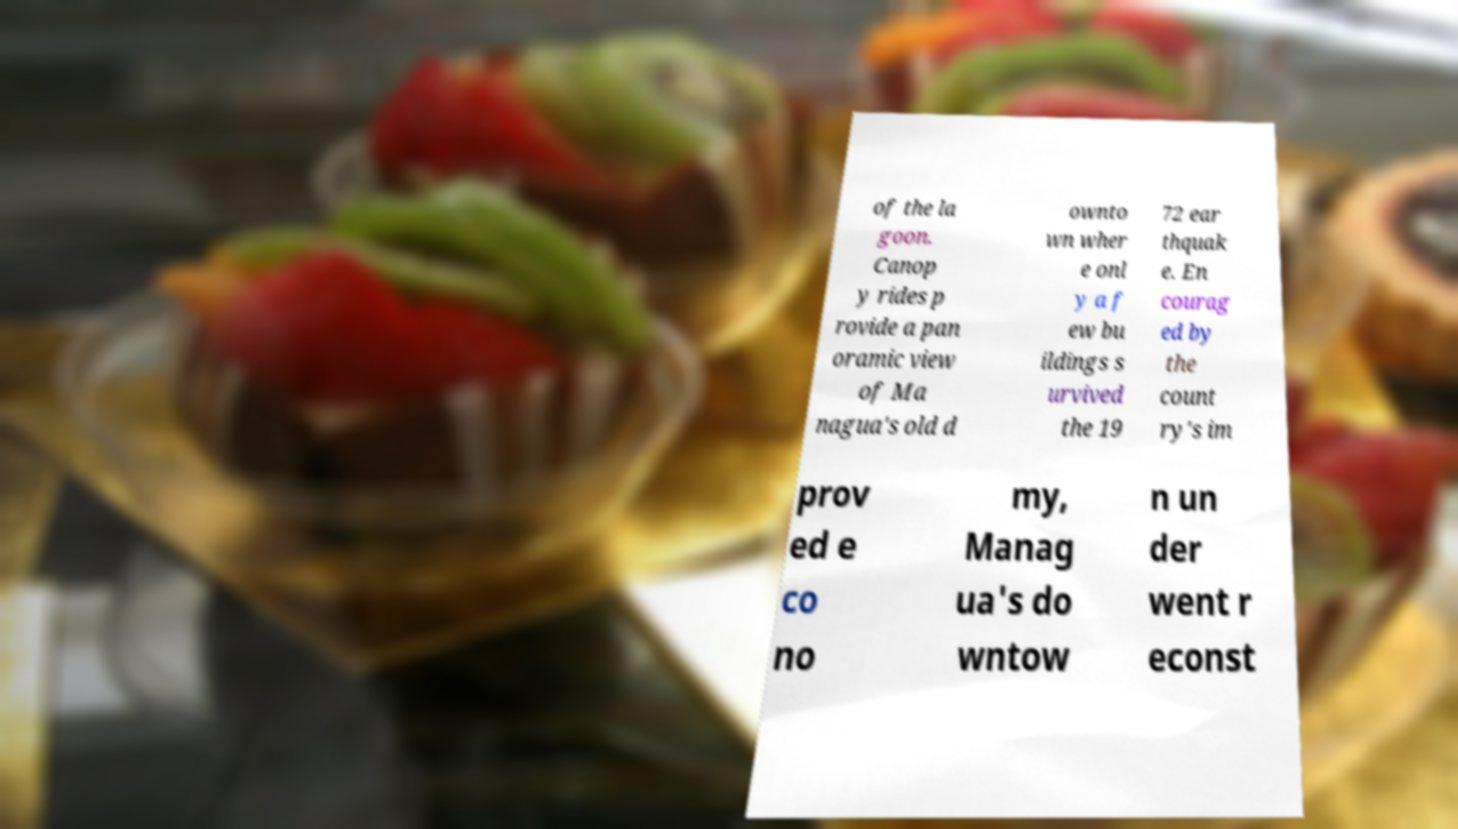I need the written content from this picture converted into text. Can you do that? of the la goon. Canop y rides p rovide a pan oramic view of Ma nagua's old d ownto wn wher e onl y a f ew bu ildings s urvived the 19 72 ear thquak e. En courag ed by the count ry's im prov ed e co no my, Manag ua's do wntow n un der went r econst 